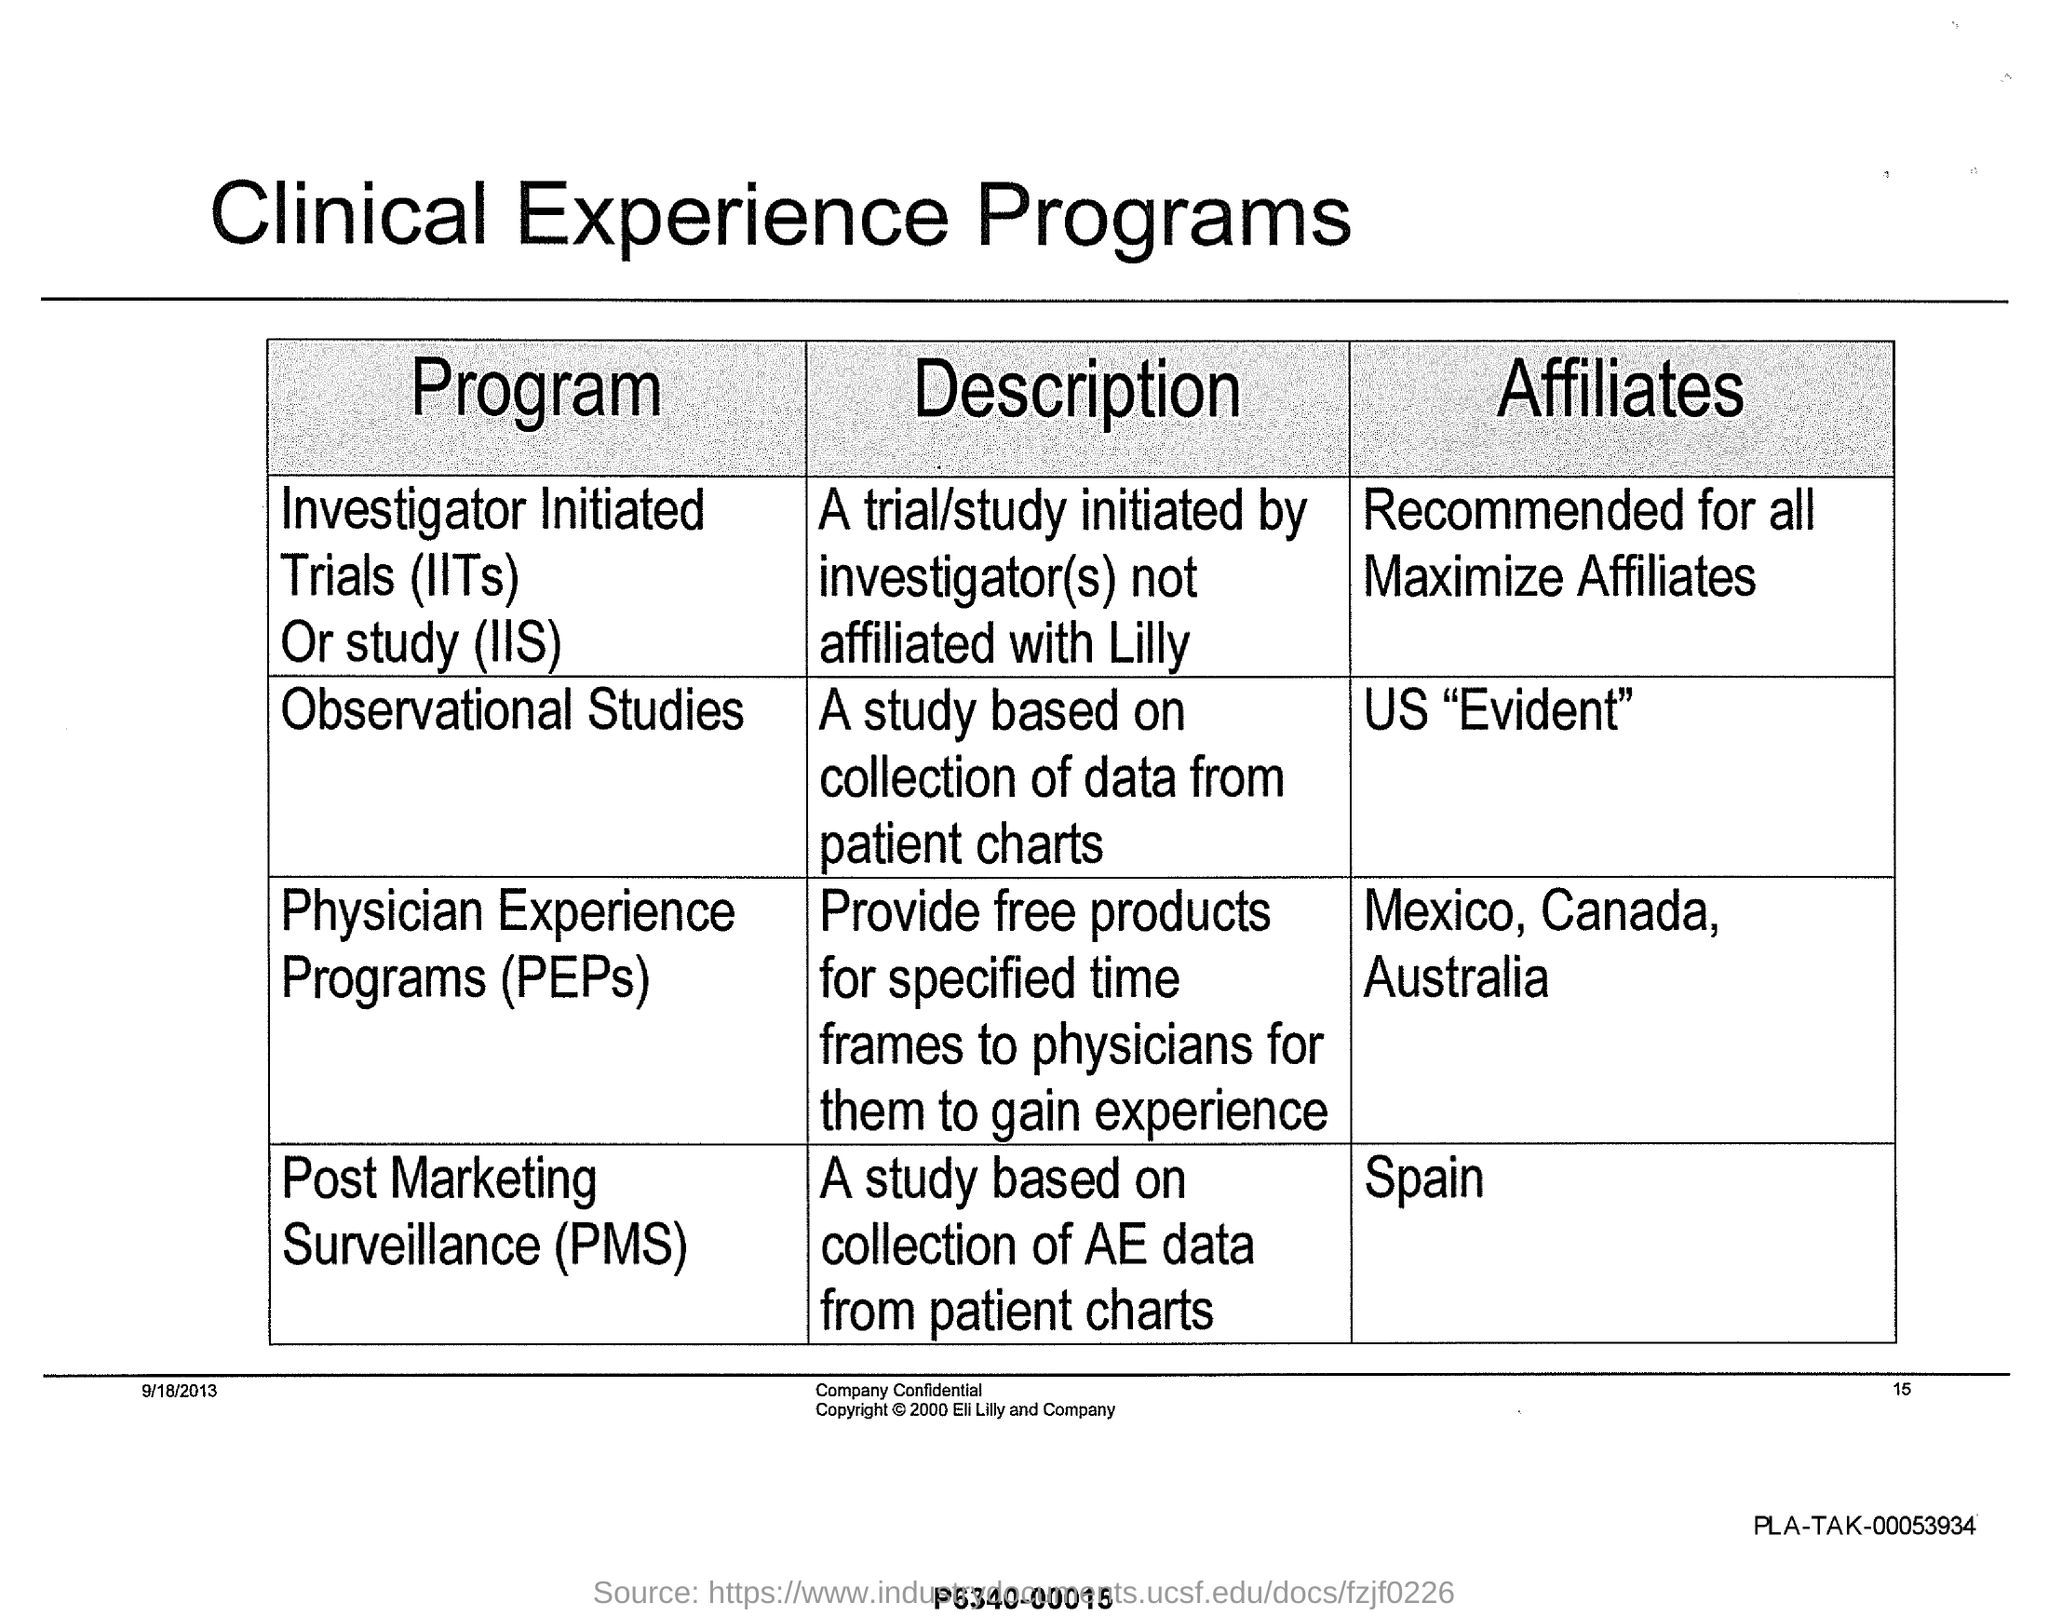Specify some key components in this picture. Investigator Initiated Trials (IITs) refer to clinical studies that are initiated and conducted by investigators, rather than by sponsors or research institutions. The study, which was based on the collection of data from patient charts and involved observational research, aimed to investigate the relationship between two variables of interest. Physician Experience Programs (PEPs) is a program that provides free products to physicians for specified time frames in order to gain experience. Post marketing surveillance (PMS) affiliates have been assigned to the region of Spain. This study used data collected from patient charts as part of post-marketing surveillance to investigate the effectiveness and safety of a particular treatment. 